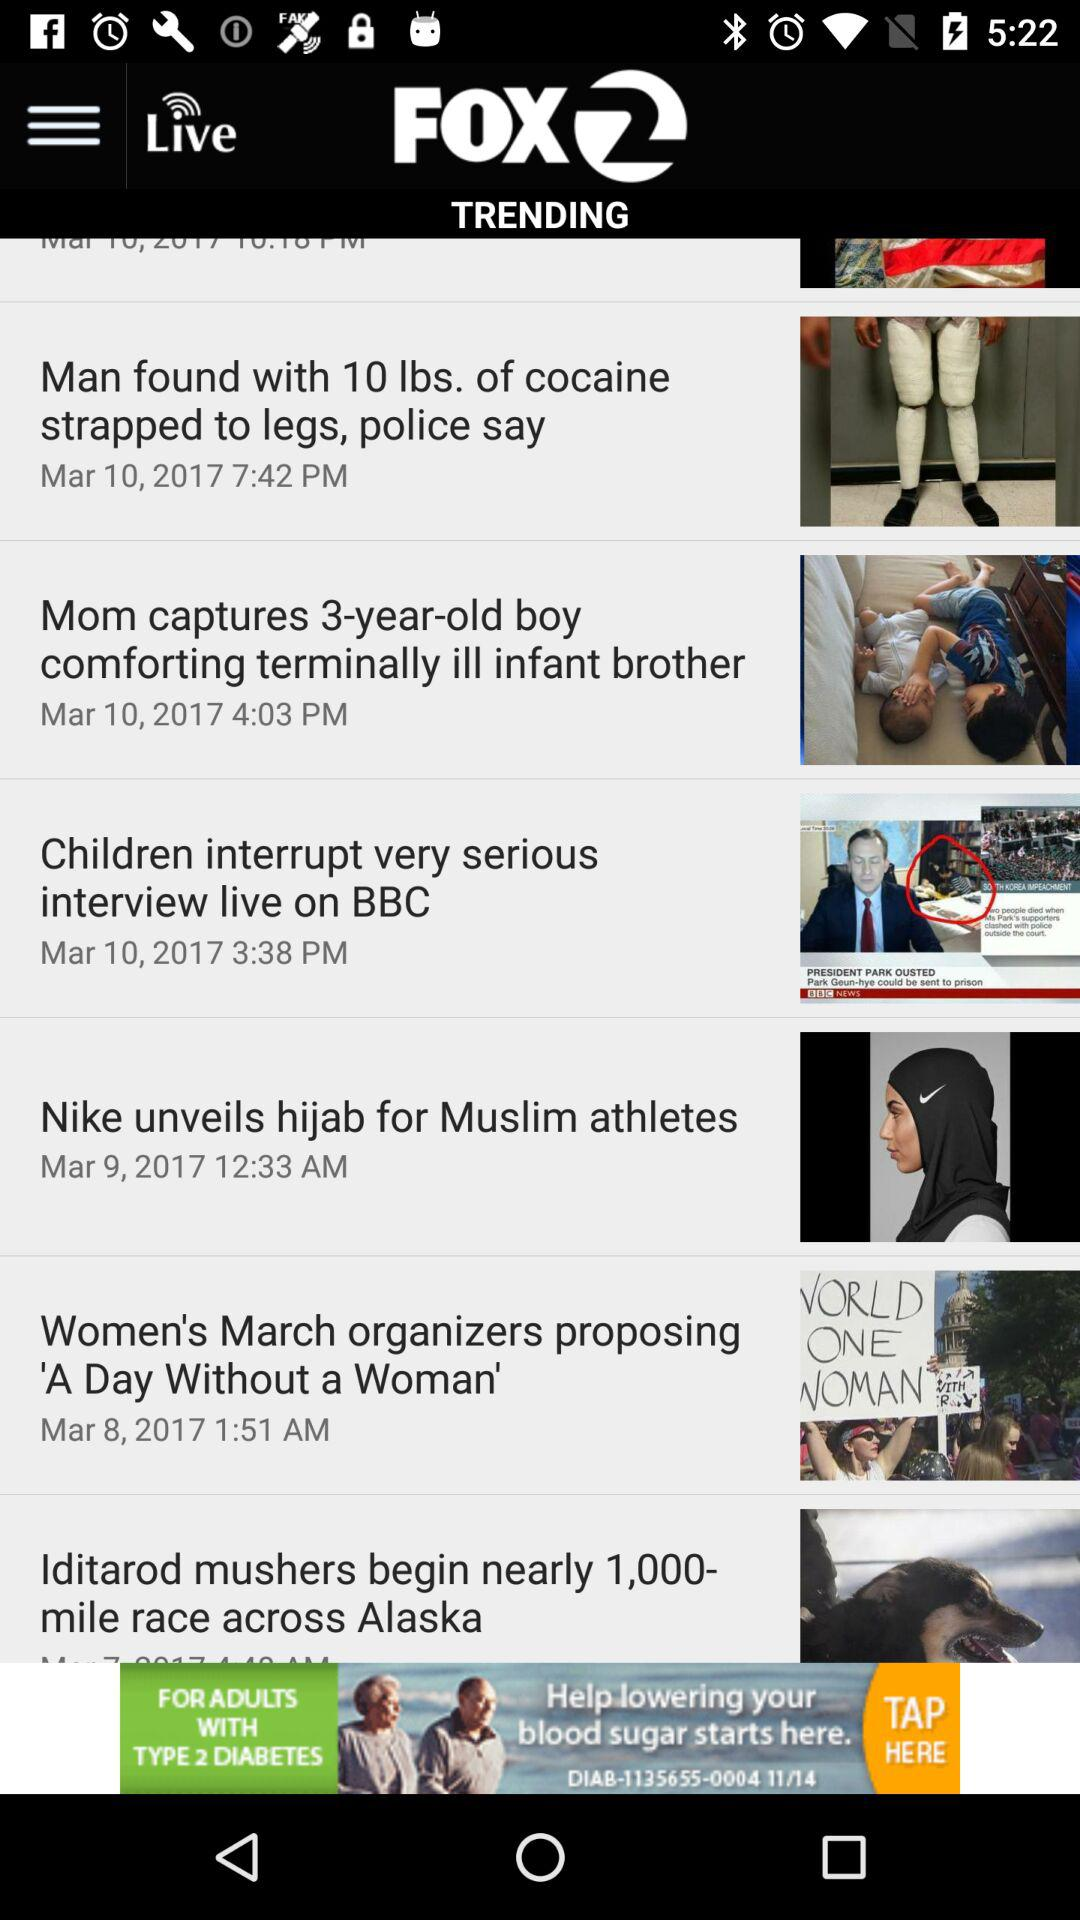What is the publication date of the article "Nike unveils hijab for Muslim athletes"? The publication date of the article "Nike unveils hijab for Muslim athletes" is March 9, 2017. 